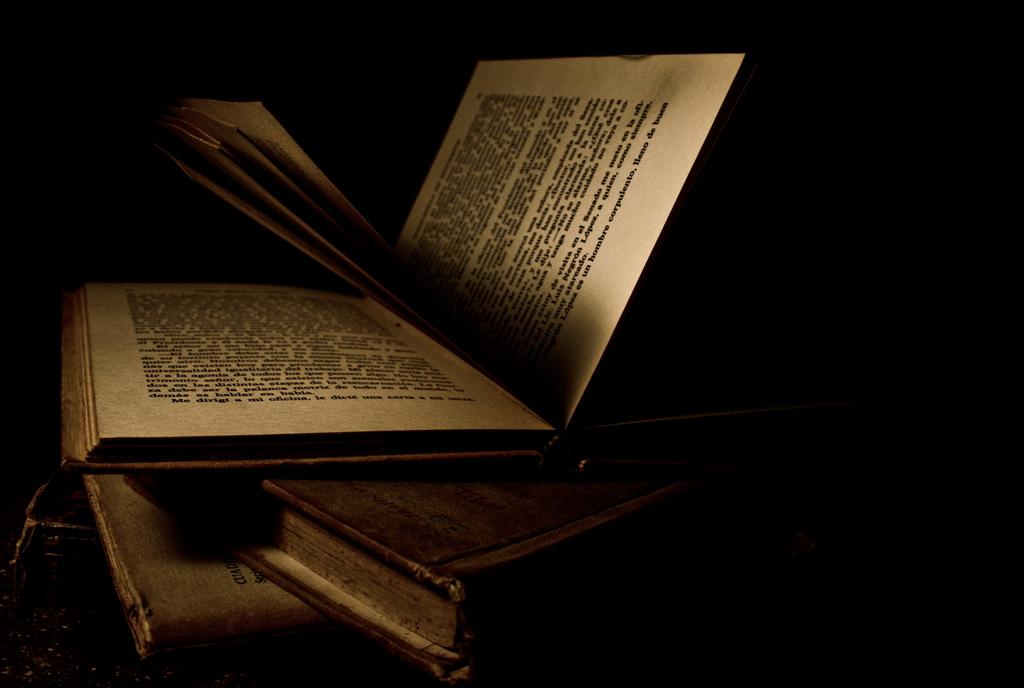<image>
Share a concise interpretation of the image provided. A book is partially open and shows foriegn texts including "Me dirigi..." at the bottom. 